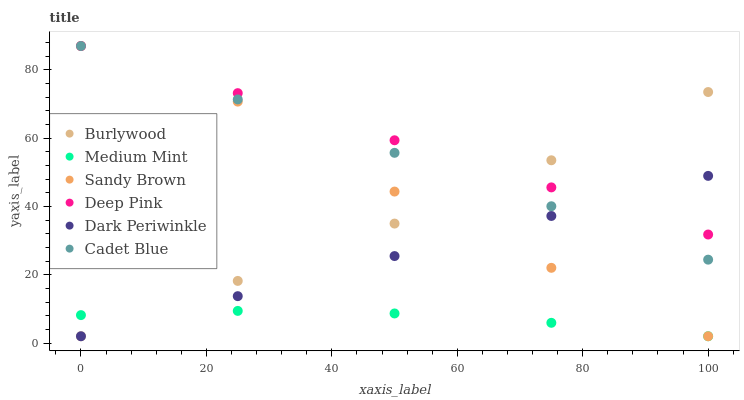Does Medium Mint have the minimum area under the curve?
Answer yes or no. Yes. Does Deep Pink have the maximum area under the curve?
Answer yes or no. Yes. Does Burlywood have the minimum area under the curve?
Answer yes or no. No. Does Burlywood have the maximum area under the curve?
Answer yes or no. No. Is Deep Pink the smoothest?
Answer yes or no. Yes. Is Sandy Brown the roughest?
Answer yes or no. Yes. Is Burlywood the smoothest?
Answer yes or no. No. Is Burlywood the roughest?
Answer yes or no. No. Does Medium Mint have the lowest value?
Answer yes or no. Yes. Does Deep Pink have the lowest value?
Answer yes or no. No. Does Sandy Brown have the highest value?
Answer yes or no. Yes. Does Burlywood have the highest value?
Answer yes or no. No. Is Medium Mint less than Deep Pink?
Answer yes or no. Yes. Is Deep Pink greater than Medium Mint?
Answer yes or no. Yes. Does Sandy Brown intersect Dark Periwinkle?
Answer yes or no. Yes. Is Sandy Brown less than Dark Periwinkle?
Answer yes or no. No. Is Sandy Brown greater than Dark Periwinkle?
Answer yes or no. No. Does Medium Mint intersect Deep Pink?
Answer yes or no. No. 